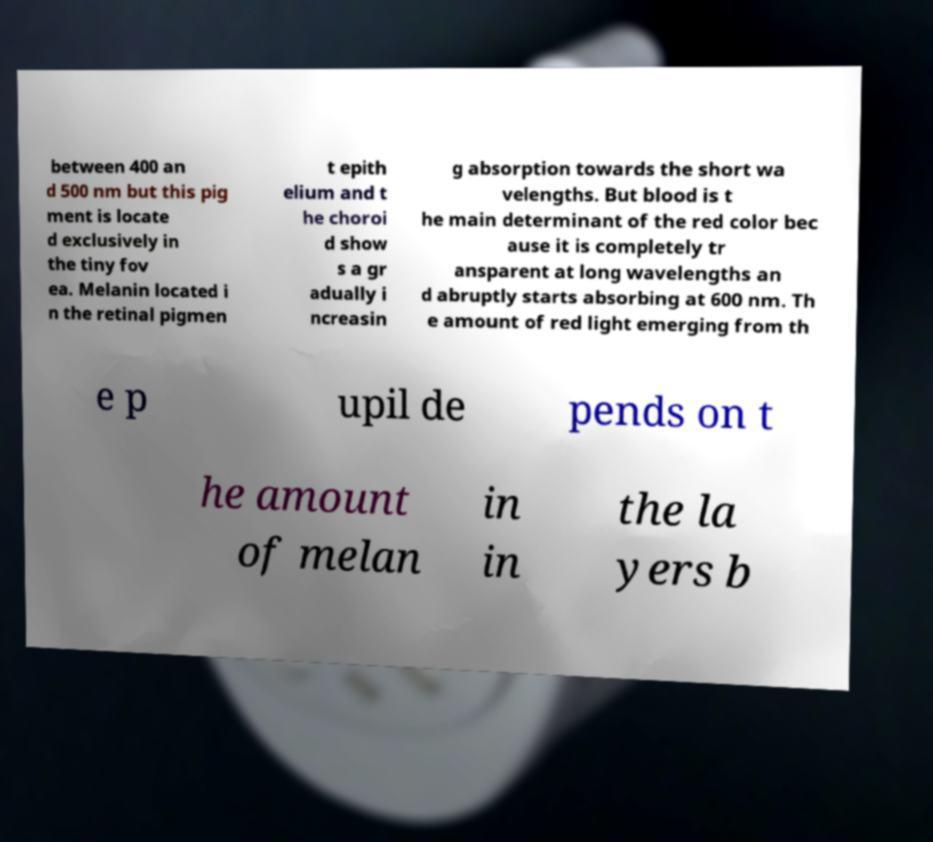Could you extract and type out the text from this image? between 400 an d 500 nm but this pig ment is locate d exclusively in the tiny fov ea. Melanin located i n the retinal pigmen t epith elium and t he choroi d show s a gr adually i ncreasin g absorption towards the short wa velengths. But blood is t he main determinant of the red color bec ause it is completely tr ansparent at long wavelengths an d abruptly starts absorbing at 600 nm. Th e amount of red light emerging from th e p upil de pends on t he amount of melan in in the la yers b 